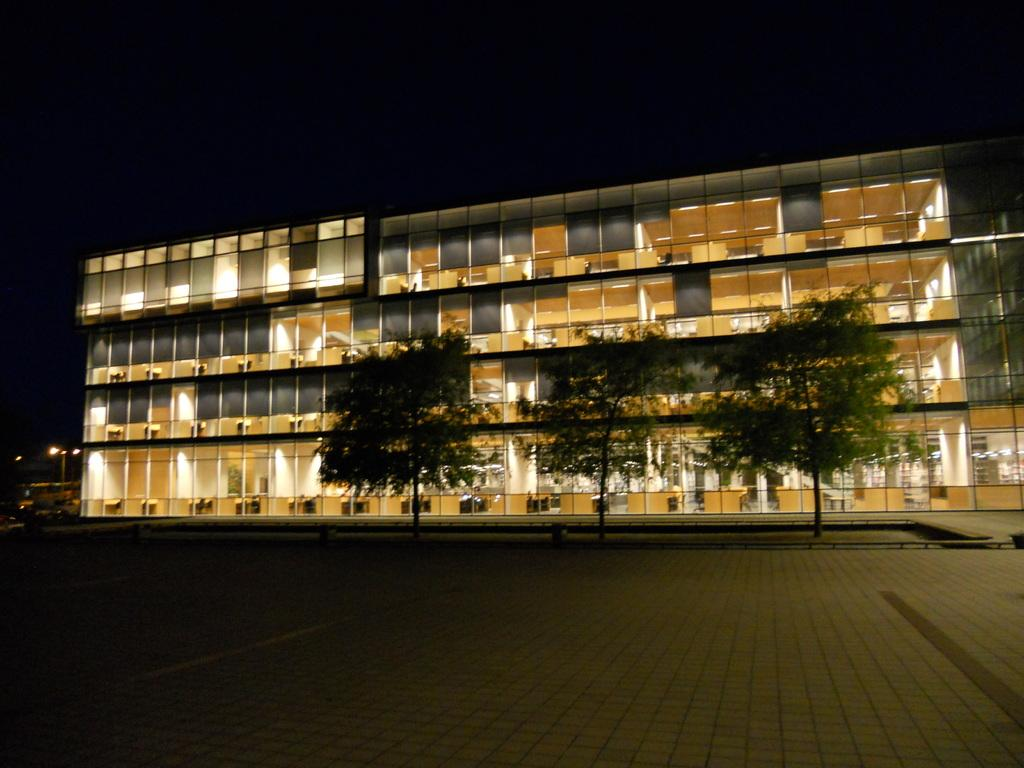What type of vegetation can be seen in the image? There are trees in the image. What can be seen illuminating the scene in the image? There are lights in the image. What type of structure is present in the image? There is a building in the image. What is visible in the background of the image? The sky is visible in the background of the image. Can you tell me how many owls are sitting on the branches of the trees in the image? There are no owls present in the image; it only features trees, lights, a building, and the sky. What type of fruit can be seen hanging from the branches of the trees in the image? There is no fruit visible on the trees in the image. 